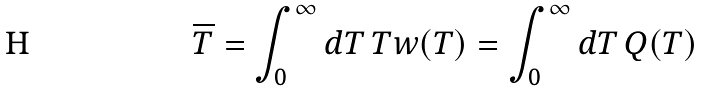<formula> <loc_0><loc_0><loc_500><loc_500>\overline { T } = \int _ { 0 } ^ { \infty } d T \, T w ( T ) = \int _ { 0 } ^ { \infty } d T \, Q ( T )</formula> 